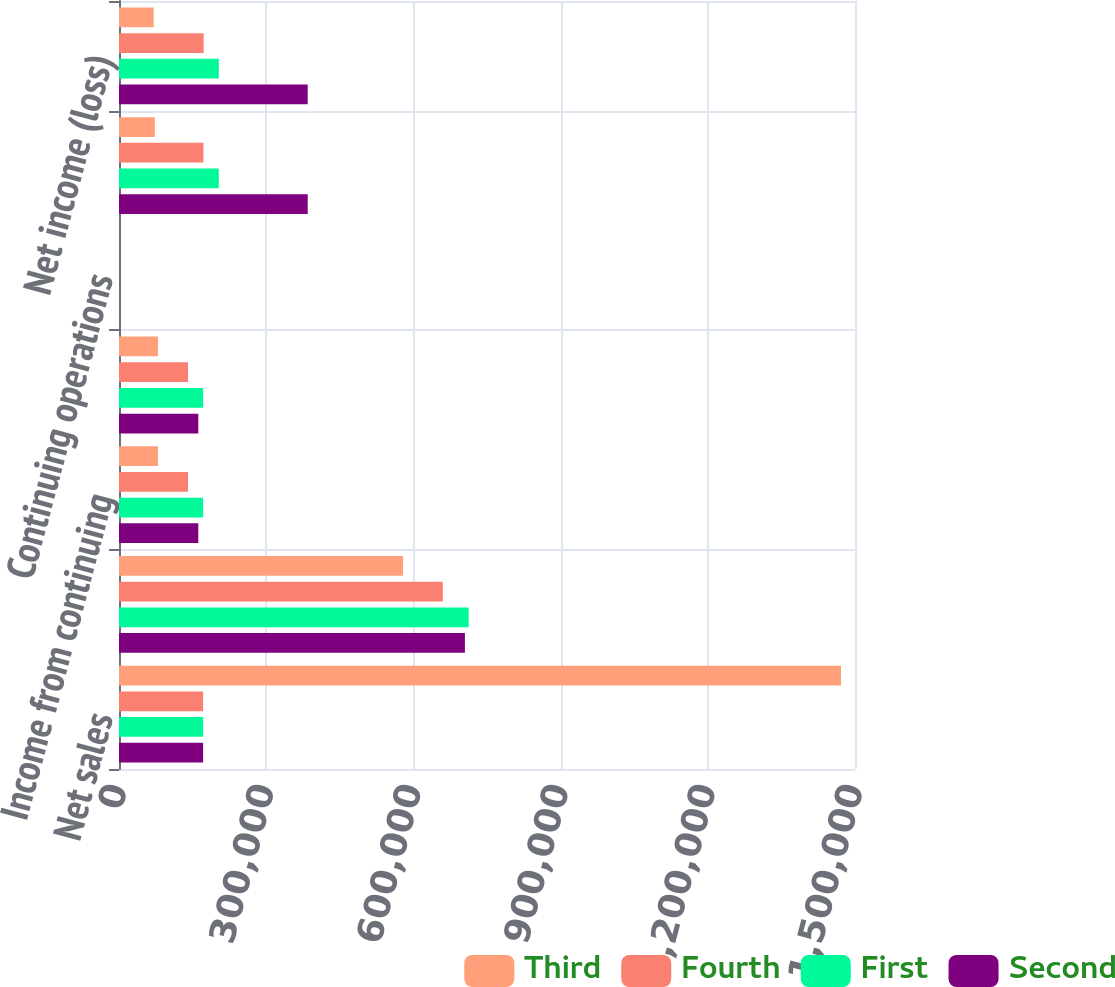Convert chart to OTSL. <chart><loc_0><loc_0><loc_500><loc_500><stacked_bar_chart><ecel><fcel>Net sales<fcel>Gross profit<fcel>Income from continuing<fcel>Net income<fcel>Continuing operations<fcel>Income (loss) from continuing<fcel>Net income (loss)<nl><fcel>Third<fcel>1.4715e+06<fcel>578921<fcel>79409<fcel>79409<fcel>0.22<fcel>73082<fcel>70617<nl><fcel>Fourth<fcel>171421<fcel>659956<fcel>140633<fcel>140633<fcel>0.39<fcel>172164<fcel>172532<nl><fcel>First<fcel>171421<fcel>712667<fcel>171421<fcel>171421<fcel>0.47<fcel>203356<fcel>203356<nl><fcel>Second<fcel>171421<fcel>704975<fcel>161621<fcel>161621<fcel>0.44<fcel>384611<fcel>384611<nl></chart> 